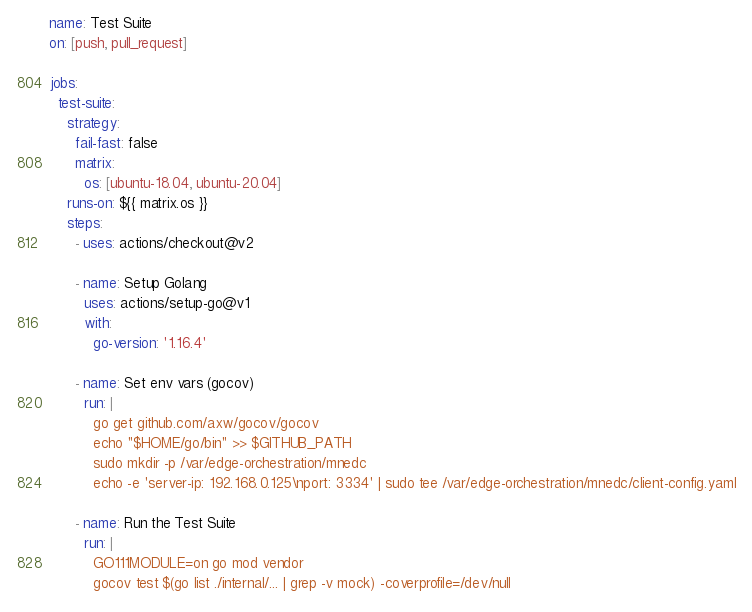Convert code to text. <code><loc_0><loc_0><loc_500><loc_500><_YAML_>name: Test Suite
on: [push, pull_request]

jobs:
  test-suite:
    strategy:
      fail-fast: false
      matrix:
        os: [ubuntu-18.04, ubuntu-20.04]
    runs-on: ${{ matrix.os }}
    steps:
      - uses: actions/checkout@v2

      - name: Setup Golang
        uses: actions/setup-go@v1
        with:
          go-version: '1.16.4'

      - name: Set env vars (gocov)
        run: |
          go get github.com/axw/gocov/gocov
          echo "$HOME/go/bin" >> $GITHUB_PATH
          sudo mkdir -p /var/edge-orchestration/mnedc
          echo -e 'server-ip: 192.168.0.125\nport: 3334' | sudo tee /var/edge-orchestration/mnedc/client-config.yaml

      - name: Run the Test Suite
        run: |
          GO111MODULE=on go mod vendor
          gocov test $(go list ./internal/... | grep -v mock) -coverprofile=/dev/null
</code> 